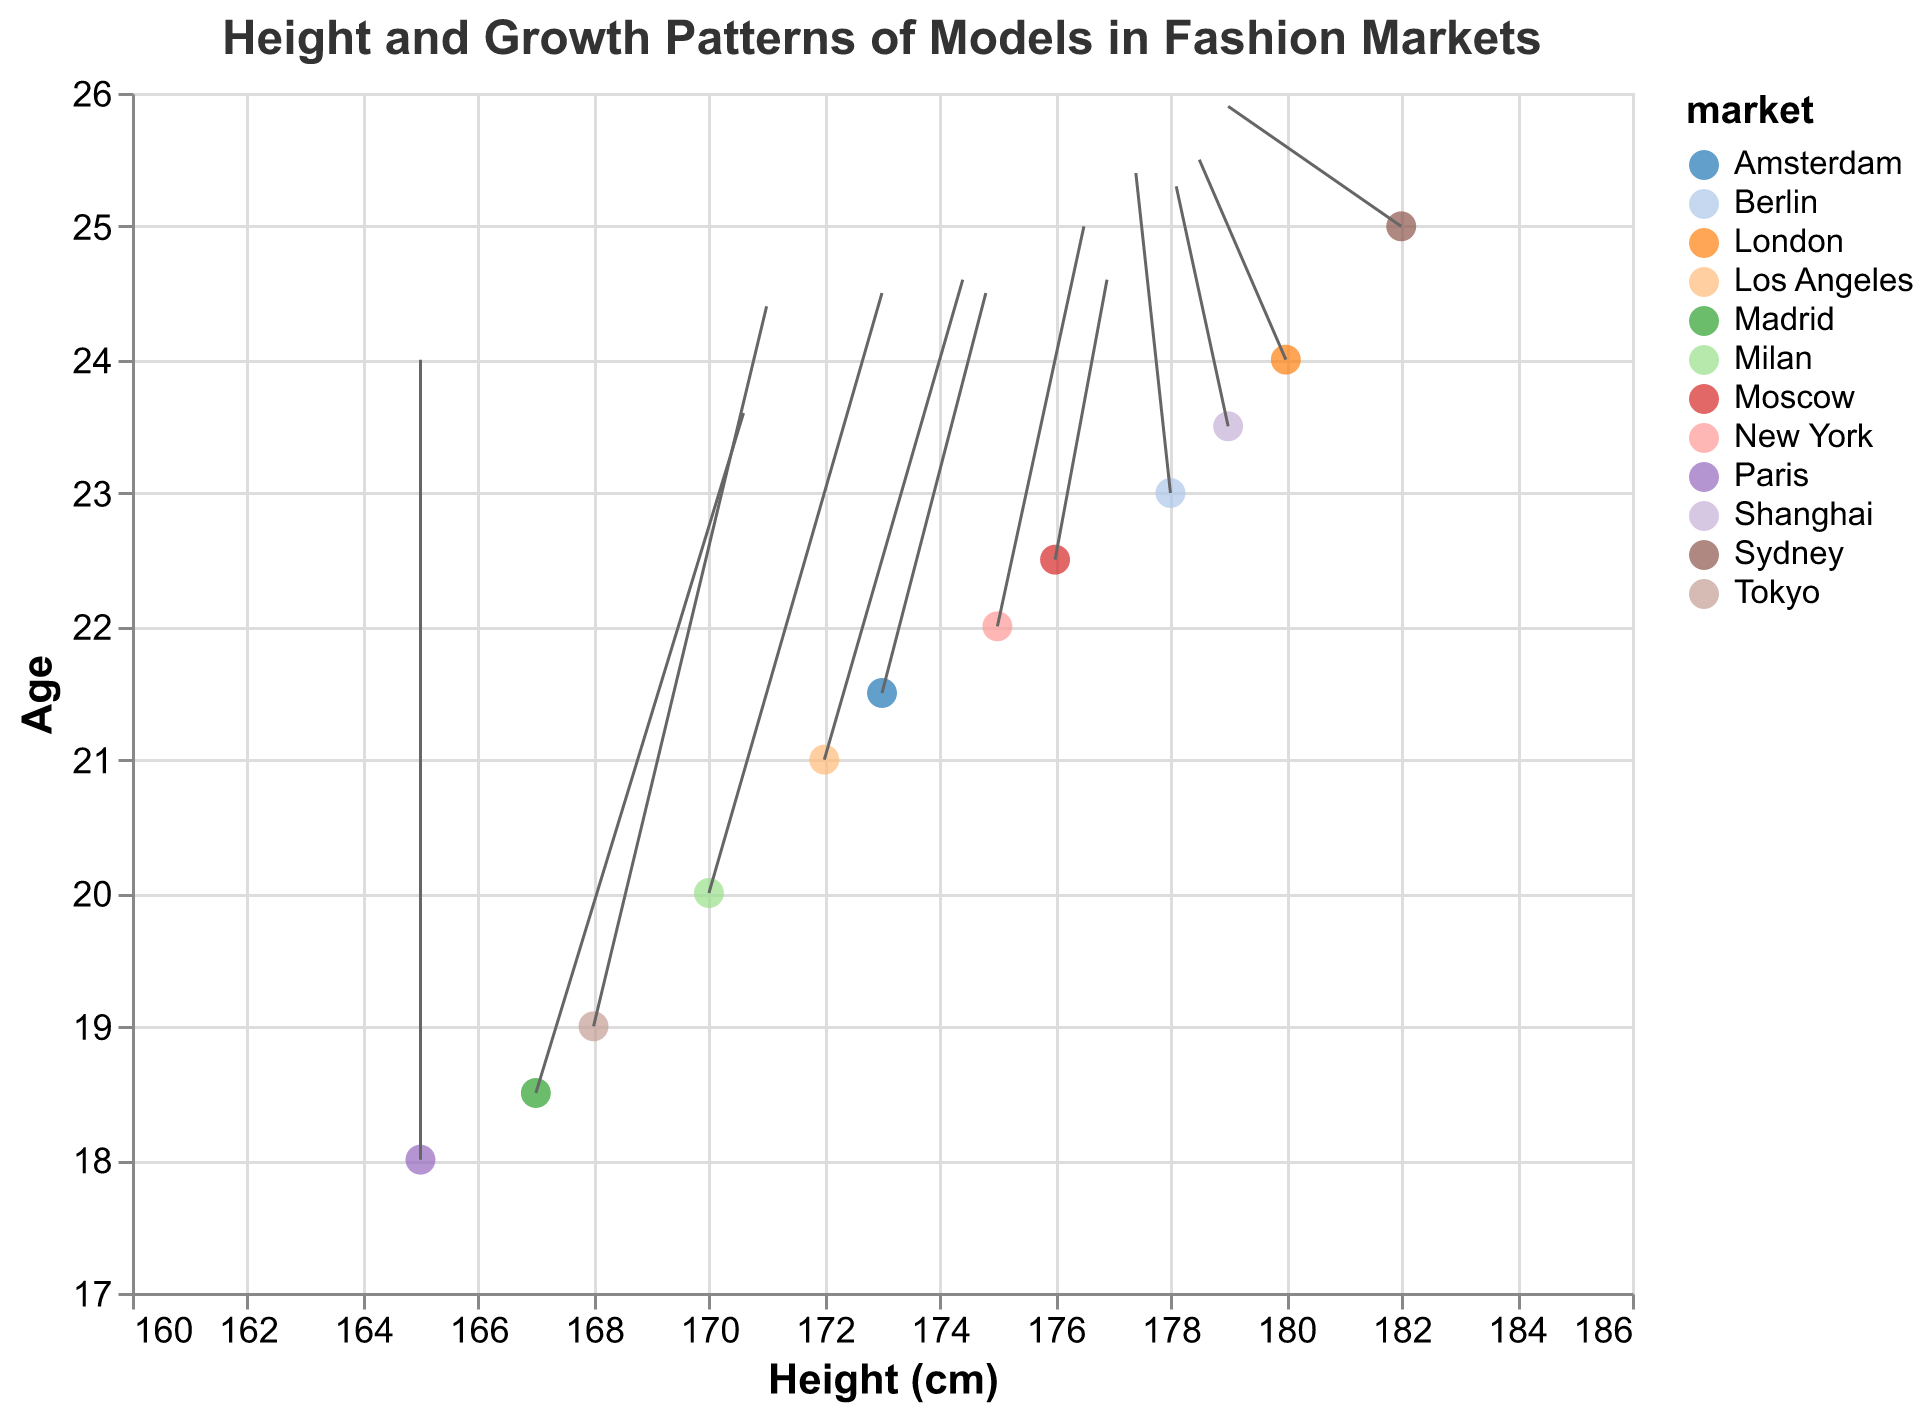What is the title of the figure? The title is located at the top of the figure and describes the main topic of the plot.
Answer: Height and Growth Patterns of Models in Fashion Markets How many data points represent the fashion market of Tokyo? We count the number of data points that have the market labeled as "Tokyo". There is only one data point for Tokyo.
Answer: 1 Which market has the tallest models based on the initial height? To find the tallest models, we look at the height (x-axis) and identify which market has the highest value. The data point for Sydney has the highest height of 182 cm.
Answer: Sydney What is the age and height of the model from Madrid? We look for the data point labeled "Madrid" and read off the values on the x-axis (height) and y-axis (age). The model from Madrid has a height of 167 cm and age 18.5.
Answer: Age: 18.5, Height: 167 cm Compare the growth patterns (both x and y directions) between models in New York and London. The vectors originating from New York and London show their growth patterns. New York's vector goes (0.5, 1) while London's vector goes (-0.5, 0.5). New York models are growing slightly in both height and age whereas London models are decreasing in height and increasing slightly in age.
Answer: New York: (0.5, 1), London: (-0.5, 0.5) Which market shows a decrease in height over time? We identify the markets where the u-component (height change) of the vector is negative. Sydney, London, Berlin, and Shanghai all show a decrease in height.
Answer: Sydney, London, Berlin, Shanghai By how much does the height increase for models in Milan? The size of the height component of the vector for Milan can be determined by looking at the 'u' value for this data point, which is 1. This value indicates a height increase.
Answer: 1 cm What is the average age of models from the given markets? Calculate the average of all y-values (ages) given: \( \frac{18 + 20 + 22 + 24 + 19 + 21 + 23 + 25 + 18.5 + 21.5 + 22.5 + 23.5}{12} = \frac{258}{12} \)
Answer: 21.5 Which market's models show the most significant upward age growth on this plot? The size of the age component of the vector (v) should be compared across markets. Tokyo has the highest positive 'v' value of 1.8 among all markets, indicating the most significant upward age growth.
Answer: Tokyo 